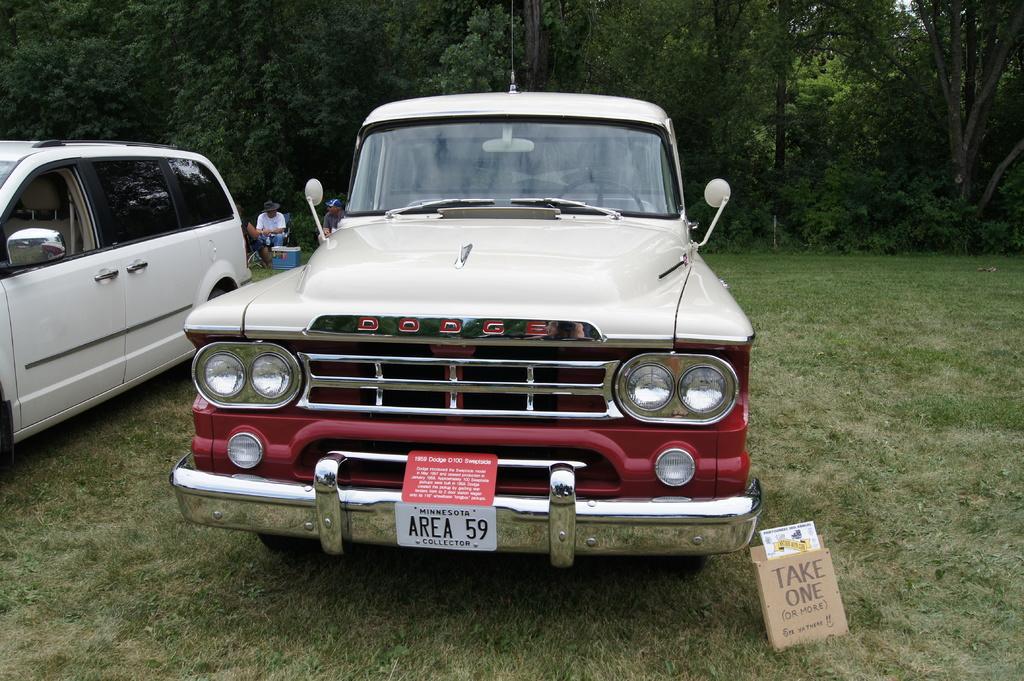Describe this image in one or two sentences. As we can see in the image there are cars, box, grass, a man sitting on chair and there are trees. 